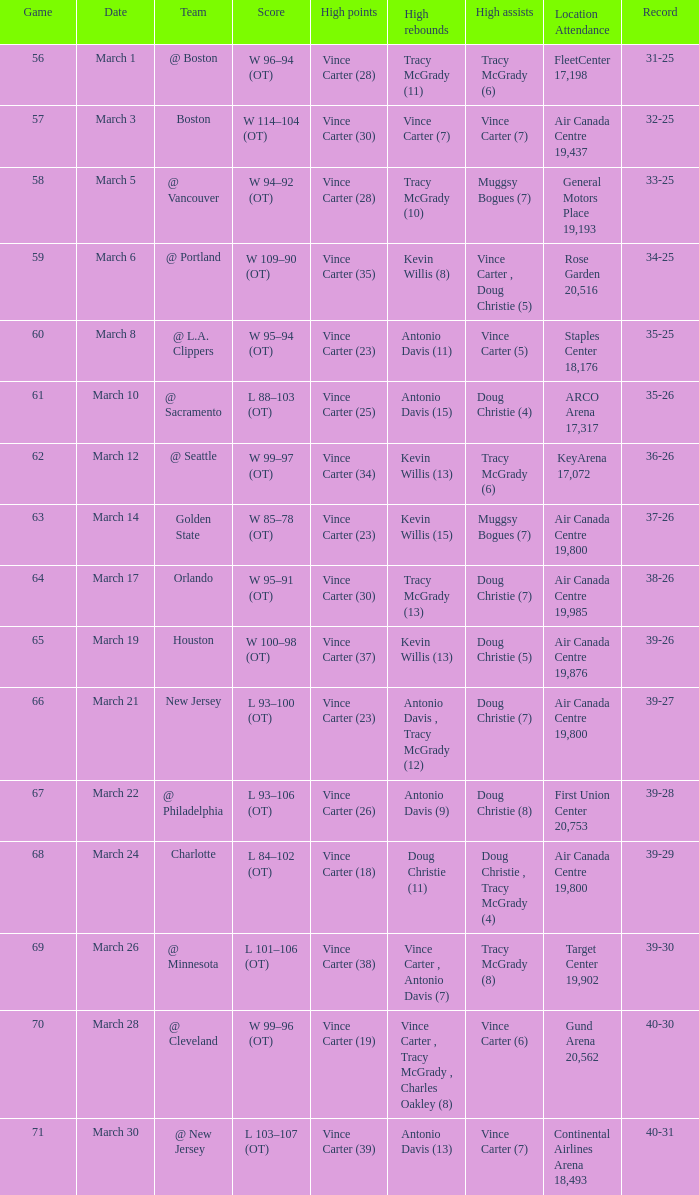Where did the team play and what was the attendance against new jersey? Air Canada Centre 19,800. 